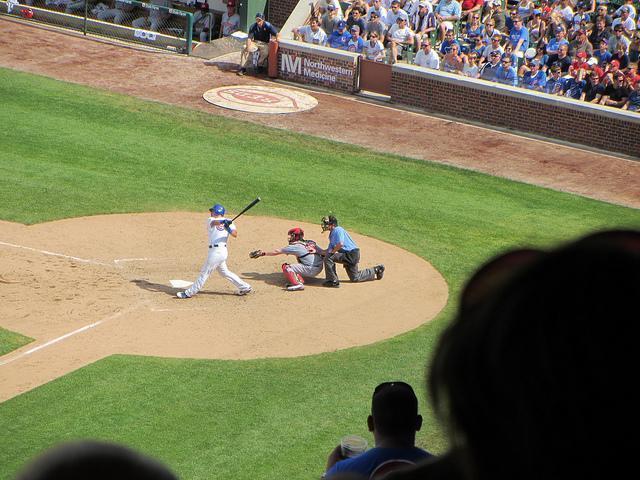What does Northwestern Medicine provide in this game?
Answer the question by selecting the correct answer among the 4 following choices and explain your choice with a short sentence. The answer should be formatted with the following format: `Answer: choice
Rationale: rationale.`
Options: Medical service, medical advice, drugs, sponsor. Answer: sponsor.
Rationale: The group is a sponsor. 